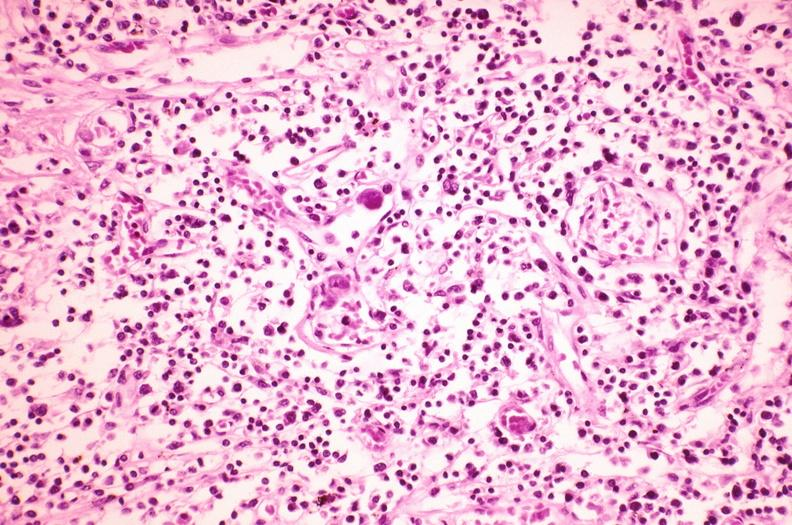what does this image show?
Answer the question using a single word or phrase. Lymph node 